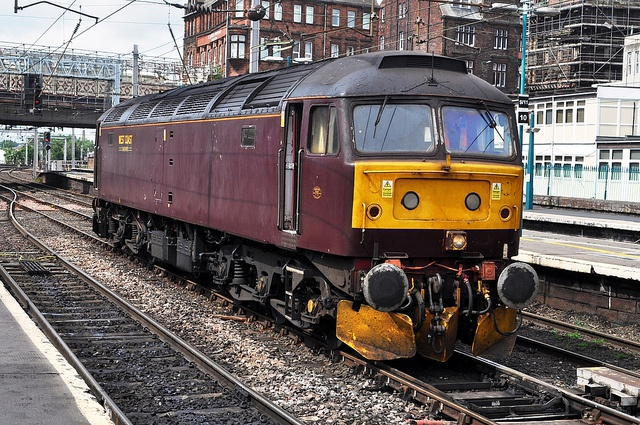Describe the objects in this image and their specific colors. I can see train in white, black, gray, maroon, and darkgray tones, people in white, gray, and darkgray tones, traffic light in white, black, gray, maroon, and darkgray tones, traffic light in white, black, gray, darkgray, and darkblue tones, and traffic light in black, gray, and white tones in this image. 